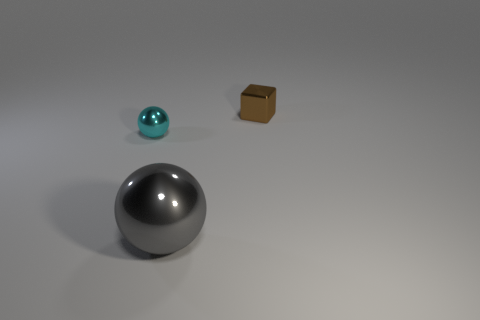Add 1 big blue rubber objects. How many objects exist? 4 Subtract all cubes. How many objects are left? 2 Add 2 cyan metallic cubes. How many cyan metallic cubes exist? 2 Subtract 0 purple cubes. How many objects are left? 3 Subtract all cyan spheres. Subtract all green blocks. How many spheres are left? 1 Subtract all blue cylinders. How many gray balls are left? 1 Subtract all tiny cyan objects. Subtract all cyan things. How many objects are left? 1 Add 1 small brown shiny blocks. How many small brown shiny blocks are left? 2 